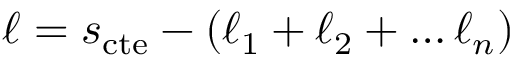Convert formula to latex. <formula><loc_0><loc_0><loc_500><loc_500>\ell = s _ { c t e } - ( \ell _ { 1 } + \ell _ { 2 } + \dots \ell _ { n } )</formula> 